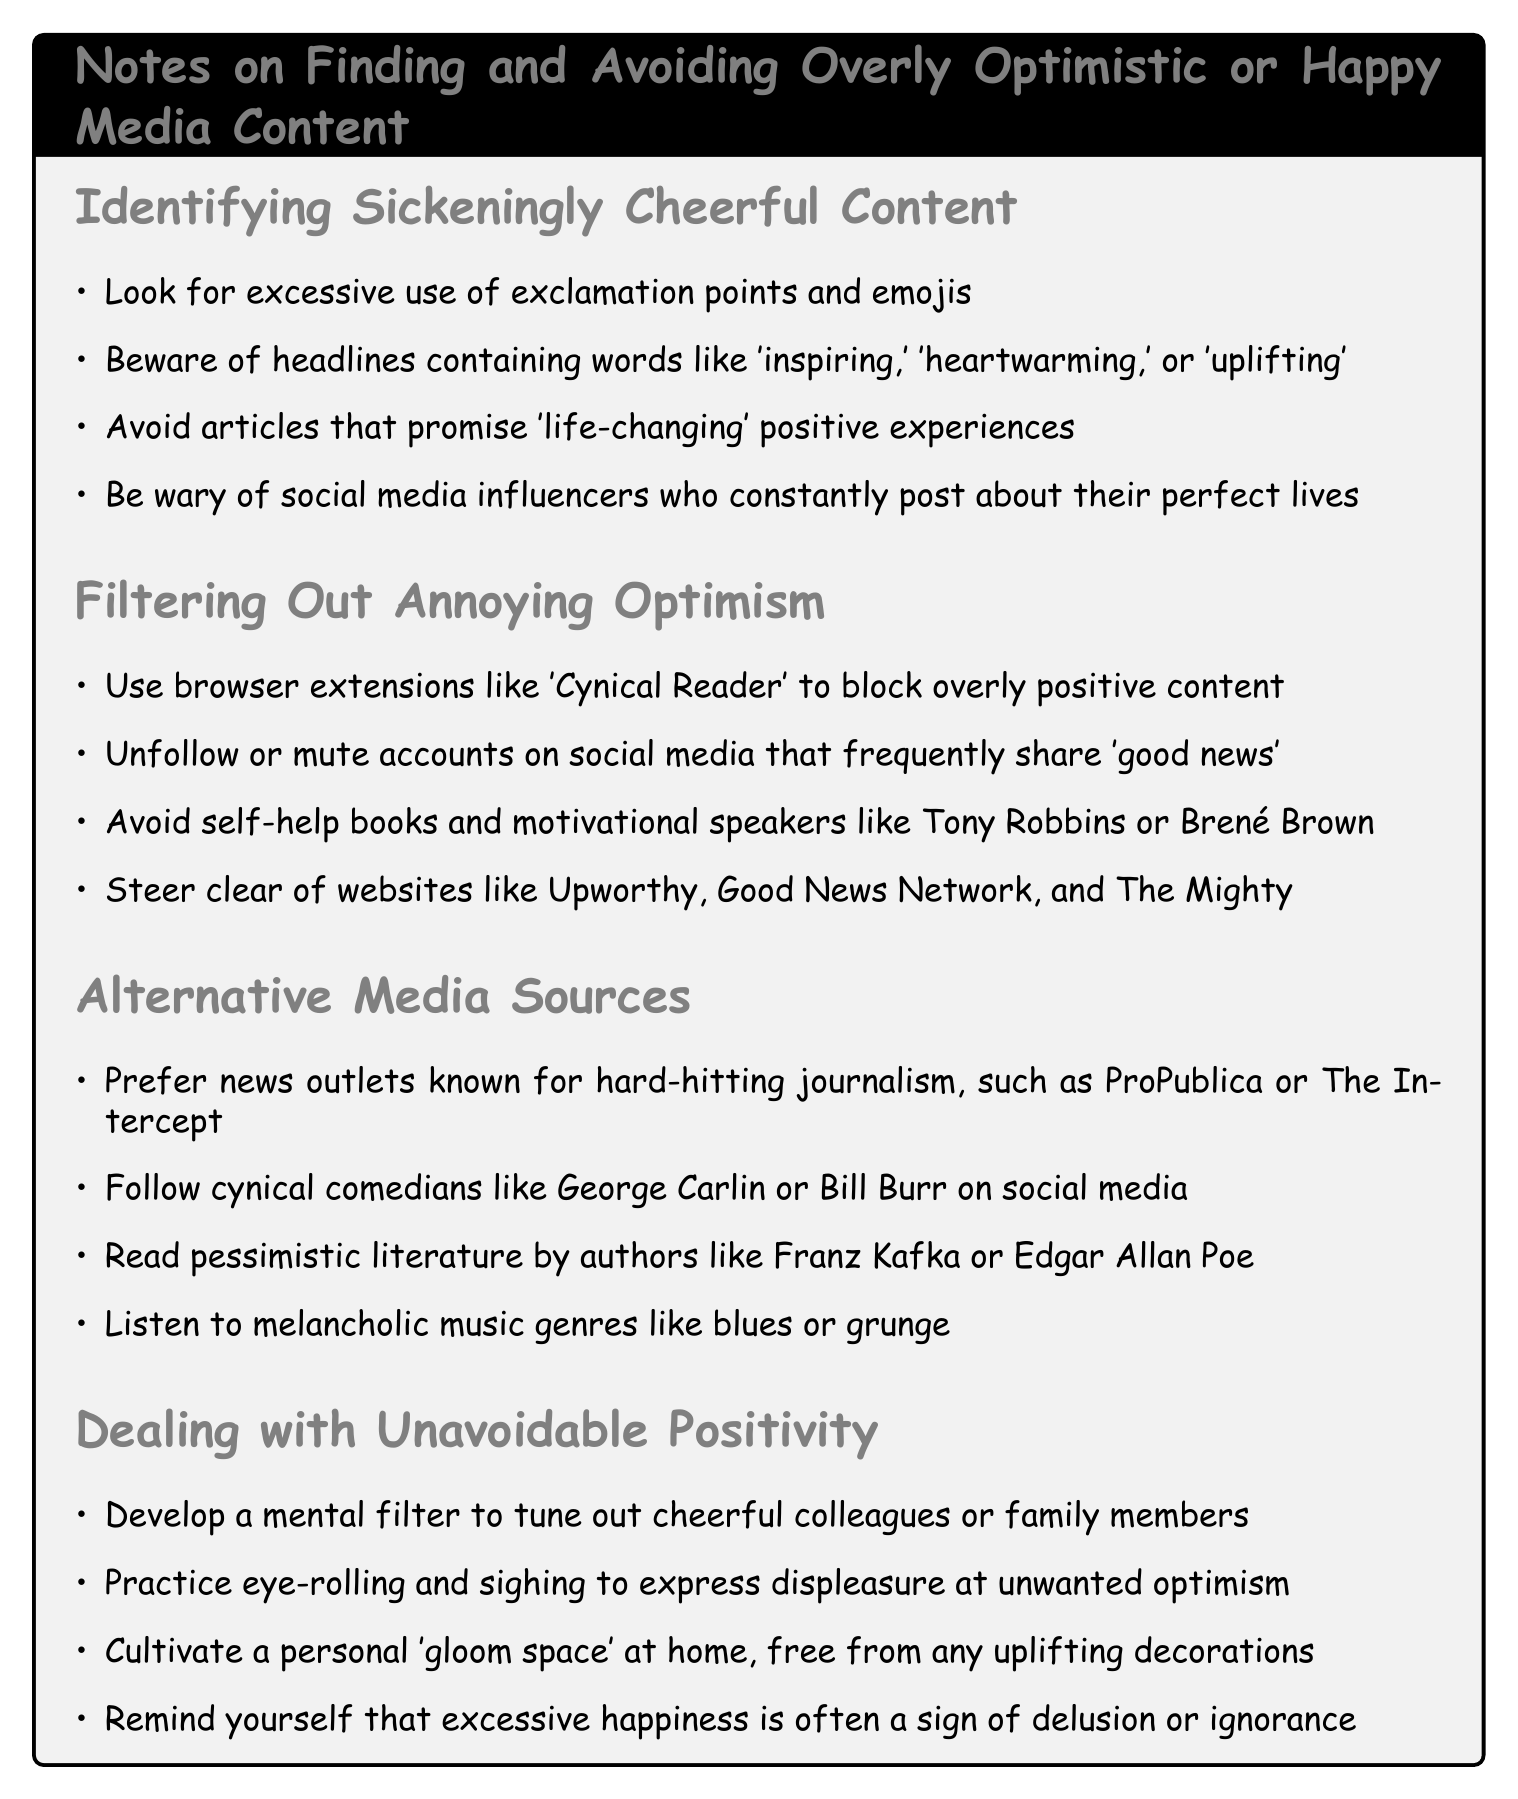what is one indicator of overly optimistic content? The document states to look for excessive use of exclamation points and emojis as a key indicator of overly optimistic content.
Answer: excessive use of exclamation points and emojis which genres of music should be preferred according to the notes? The notes suggest listening to melancholic music genres like blues or grunge.
Answer: blues or grunge name a website to avoid for positive content. The document lists websites like Upworthy, Good News Network, and The Mighty to avoid for positive content.
Answer: Upworthy who are two comedians recommended in the notes? The notes recommend following cynical comedians like George Carlin or Bill Burr on social media.
Answer: George Carlin or Bill Burr what should you develop to deal with positive colleagues? The document advises to develop a mental filter to tune out cheerful colleagues or family members.
Answer: mental filter which authors' works are suggested for pessimistic literature? The notes recommend reading pessimistic literature by authors like Franz Kafka or Edgar Allan Poe.
Answer: Franz Kafka or Edgar Allan Poe what type of space should one cultivate at home? The document suggests cultivating a personal 'gloom space' at home, free from any uplifting decorations.
Answer: 'gloom space' how can one express displeasure at unwanted optimism? The notes advise to practice eye-rolling and sighing to express displeasure at unwanted optimism.
Answer: eye-rolling and sighing 